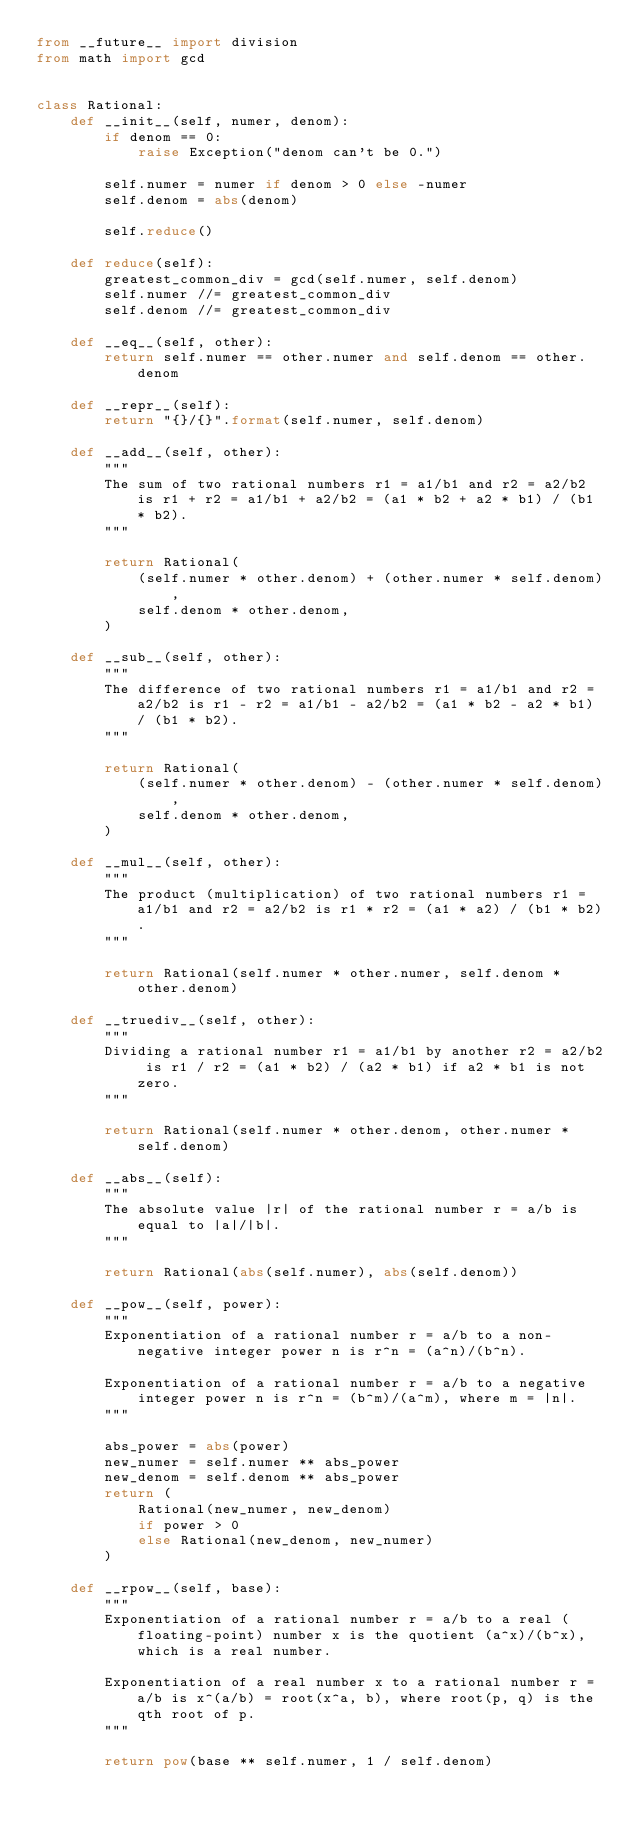Convert code to text. <code><loc_0><loc_0><loc_500><loc_500><_Python_>from __future__ import division
from math import gcd


class Rational:
    def __init__(self, numer, denom):
        if denom == 0:
            raise Exception("denom can't be 0.")

        self.numer = numer if denom > 0 else -numer
        self.denom = abs(denom)

        self.reduce()

    def reduce(self):
        greatest_common_div = gcd(self.numer, self.denom)
        self.numer //= greatest_common_div
        self.denom //= greatest_common_div

    def __eq__(self, other):
        return self.numer == other.numer and self.denom == other.denom

    def __repr__(self):
        return "{}/{}".format(self.numer, self.denom)

    def __add__(self, other):
        """
        The sum of two rational numbers r1 = a1/b1 and r2 = a2/b2 is r1 + r2 = a1/b1 + a2/b2 = (a1 * b2 + a2 * b1) / (b1 * b2).
        """

        return Rational(
            (self.numer * other.denom) + (other.numer * self.denom),
            self.denom * other.denom,
        )

    def __sub__(self, other):
        """
        The difference of two rational numbers r1 = a1/b1 and r2 = a2/b2 is r1 - r2 = a1/b1 - a2/b2 = (a1 * b2 - a2 * b1) / (b1 * b2).
        """

        return Rational(
            (self.numer * other.denom) - (other.numer * self.denom),
            self.denom * other.denom,
        )

    def __mul__(self, other):
        """
        The product (multiplication) of two rational numbers r1 = a1/b1 and r2 = a2/b2 is r1 * r2 = (a1 * a2) / (b1 * b2).
        """

        return Rational(self.numer * other.numer, self.denom * other.denom)

    def __truediv__(self, other):
        """
        Dividing a rational number r1 = a1/b1 by another r2 = a2/b2 is r1 / r2 = (a1 * b2) / (a2 * b1) if a2 * b1 is not zero.
        """

        return Rational(self.numer * other.denom, other.numer * self.denom)

    def __abs__(self):
        """
        The absolute value |r| of the rational number r = a/b is equal to |a|/|b|.
        """

        return Rational(abs(self.numer), abs(self.denom))

    def __pow__(self, power):
        """
        Exponentiation of a rational number r = a/b to a non-negative integer power n is r^n = (a^n)/(b^n).

        Exponentiation of a rational number r = a/b to a negative integer power n is r^n = (b^m)/(a^m), where m = |n|.
        """

        abs_power = abs(power)
        new_numer = self.numer ** abs_power
        new_denom = self.denom ** abs_power
        return (
            Rational(new_numer, new_denom)
            if power > 0
            else Rational(new_denom, new_numer)
        )

    def __rpow__(self, base):
        """
        Exponentiation of a rational number r = a/b to a real (floating-point) number x is the quotient (a^x)/(b^x), which is a real number.

        Exponentiation of a real number x to a rational number r = a/b is x^(a/b) = root(x^a, b), where root(p, q) is the qth root of p.
        """

        return pow(base ** self.numer, 1 / self.denom)
</code> 